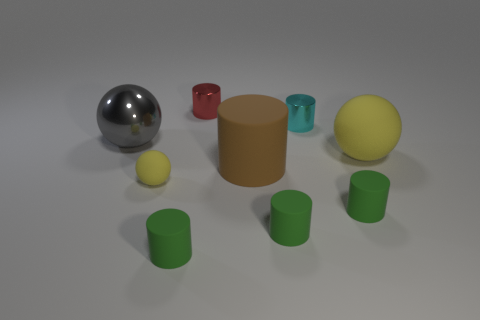Are there any big balls that have the same color as the tiny ball?
Give a very brief answer. Yes. Is the tiny matte ball the same color as the big matte sphere?
Give a very brief answer. Yes. How big is the yellow ball right of the cylinder behind the cyan metal object?
Ensure brevity in your answer.  Large. Are there fewer big brown rubber cylinders than tiny cyan shiny balls?
Offer a very short reply. No. There is a tiny object that is on the right side of the red shiny cylinder and on the left side of the cyan thing; what is it made of?
Offer a very short reply. Rubber. There is a yellow object in front of the large brown matte cylinder; is there a large sphere to the left of it?
Keep it short and to the point. Yes. How many things are yellow rubber cylinders or green things?
Provide a short and direct response. 3. The small object that is both behind the small yellow rubber ball and in front of the red metal cylinder has what shape?
Provide a succinct answer. Cylinder. Do the large ball that is to the right of the metallic ball and the brown cylinder have the same material?
Ensure brevity in your answer.  Yes. What number of things are either tiny red metallic cylinders or big gray balls that are left of the small yellow matte sphere?
Ensure brevity in your answer.  2. 